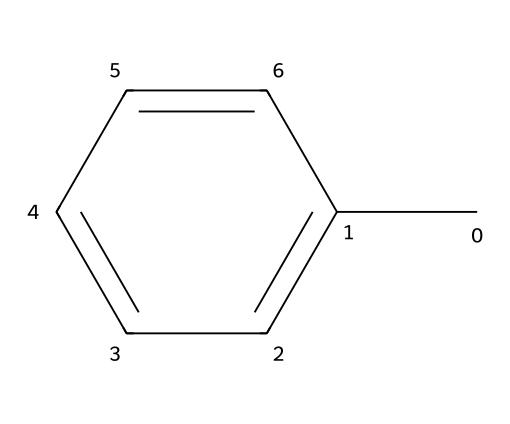How many carbon atoms are present in toluene? The SMILES representation indicates there are 7 carbon atoms (C). Each "C" in the SMILES corresponds to a carbon atom, and the linear structure suggests that there are no missing carbon atoms in the arrangement.
Answer: 7 What is the chemical structure of toluene? Toluene has a benzene ring with a methyl group attached, as denoted by the "c" and "C" in the SMILES. The lowercase "c" refers to carbon atoms in an aromatic structure, indicating a cyclic arrangement with alternating double bonds, while the uppercase "C" represents the methyl group.
Answer: benzene with a methyl group How many hydrogen atoms are in toluene? Each carbon in toluene contributes a certain number of hydrogen atoms based on its bonding. There are 7 carbon atoms, with 1 hydrogen atom lost due to the attachment of the methyl group. Thus, the total count gives 8 hydrogen atoms.
Answer: 8 What type of chemical compound is toluene classified as? Toluene is classified based on its structure as an aromatic hydrocarbon with a functional group. The presence of the benzene ring leads to its identification as an aromatic, and the methyl group confirms it as an alkyl-substituted aromatic hydrocarbon.
Answer: aromatic hydrocarbon What property of toluene makes it useful in adhesives? The non-polar solvent property of toluene allows it to dissolve various types of polymers and organic compounds, making it effective for use in adhesives. Its aromatic structure contributes to low polarity and volatility, enhancing its function as a solvent.
Answer: non-polar solvent How does the arrangement of toluene affect its volatility? The molecular arrangement of toluene, particularly the compact benzene ring and the methyl group, influences its ability to evaporate. The structure leads to relatively low boiling points compared to higher molecular weight compounds, aiding in its volatility characteristics.
Answer: compactness 